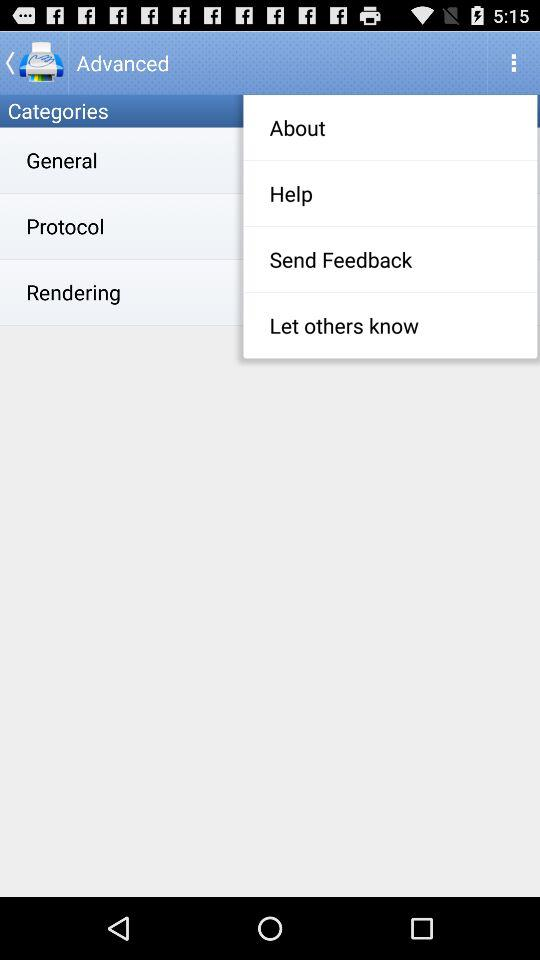How many categories are there?
Answer the question using a single word or phrase. 3 